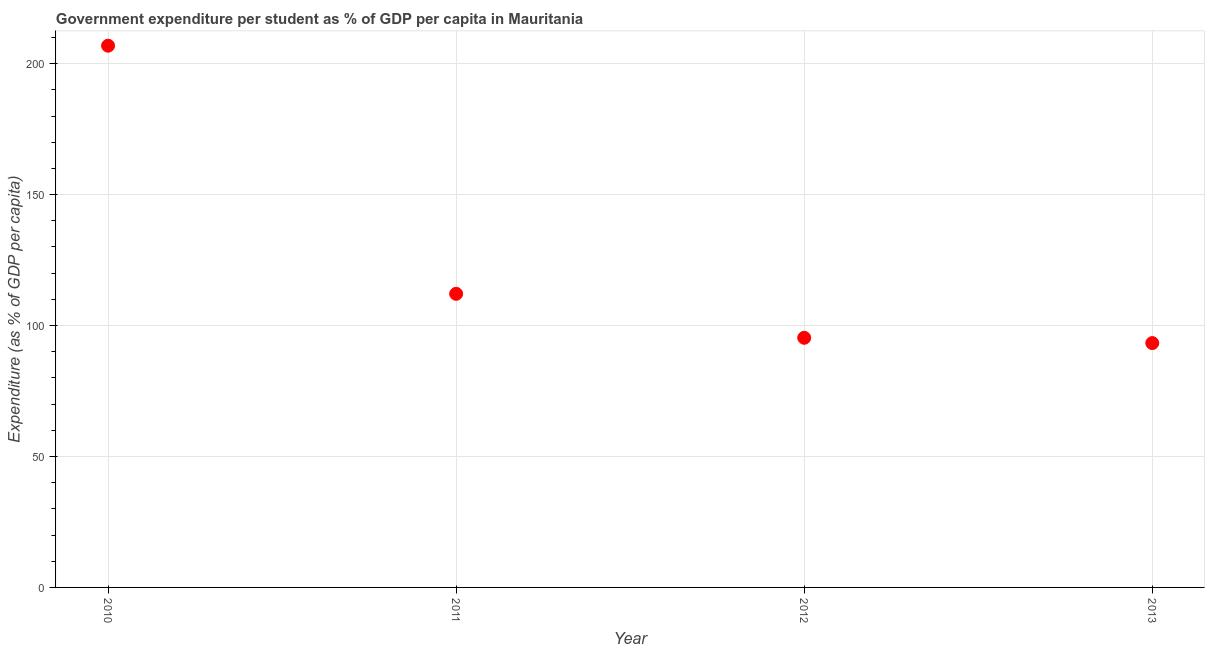What is the government expenditure per student in 2012?
Keep it short and to the point. 95.32. Across all years, what is the maximum government expenditure per student?
Your answer should be compact. 206.85. Across all years, what is the minimum government expenditure per student?
Make the answer very short. 93.3. In which year was the government expenditure per student maximum?
Ensure brevity in your answer.  2010. What is the sum of the government expenditure per student?
Ensure brevity in your answer.  507.58. What is the difference between the government expenditure per student in 2010 and 2011?
Keep it short and to the point. 94.74. What is the average government expenditure per student per year?
Your answer should be very brief. 126.9. What is the median government expenditure per student?
Give a very brief answer. 103.72. Do a majority of the years between 2011 and 2010 (inclusive) have government expenditure per student greater than 20 %?
Make the answer very short. No. What is the ratio of the government expenditure per student in 2010 to that in 2012?
Your answer should be compact. 2.17. Is the government expenditure per student in 2010 less than that in 2012?
Provide a succinct answer. No. What is the difference between the highest and the second highest government expenditure per student?
Ensure brevity in your answer.  94.74. What is the difference between the highest and the lowest government expenditure per student?
Offer a very short reply. 113.55. In how many years, is the government expenditure per student greater than the average government expenditure per student taken over all years?
Provide a short and direct response. 1. How many years are there in the graph?
Your answer should be very brief. 4. What is the difference between two consecutive major ticks on the Y-axis?
Provide a short and direct response. 50. Does the graph contain any zero values?
Your response must be concise. No. What is the title of the graph?
Your answer should be very brief. Government expenditure per student as % of GDP per capita in Mauritania. What is the label or title of the X-axis?
Your answer should be very brief. Year. What is the label or title of the Y-axis?
Offer a very short reply. Expenditure (as % of GDP per capita). What is the Expenditure (as % of GDP per capita) in 2010?
Your response must be concise. 206.85. What is the Expenditure (as % of GDP per capita) in 2011?
Provide a short and direct response. 112.11. What is the Expenditure (as % of GDP per capita) in 2012?
Your answer should be compact. 95.32. What is the Expenditure (as % of GDP per capita) in 2013?
Your answer should be very brief. 93.3. What is the difference between the Expenditure (as % of GDP per capita) in 2010 and 2011?
Provide a short and direct response. 94.74. What is the difference between the Expenditure (as % of GDP per capita) in 2010 and 2012?
Your answer should be compact. 111.53. What is the difference between the Expenditure (as % of GDP per capita) in 2010 and 2013?
Provide a succinct answer. 113.55. What is the difference between the Expenditure (as % of GDP per capita) in 2011 and 2012?
Your answer should be compact. 16.79. What is the difference between the Expenditure (as % of GDP per capita) in 2011 and 2013?
Make the answer very short. 18.81. What is the difference between the Expenditure (as % of GDP per capita) in 2012 and 2013?
Give a very brief answer. 2.02. What is the ratio of the Expenditure (as % of GDP per capita) in 2010 to that in 2011?
Ensure brevity in your answer.  1.84. What is the ratio of the Expenditure (as % of GDP per capita) in 2010 to that in 2012?
Give a very brief answer. 2.17. What is the ratio of the Expenditure (as % of GDP per capita) in 2010 to that in 2013?
Your response must be concise. 2.22. What is the ratio of the Expenditure (as % of GDP per capita) in 2011 to that in 2012?
Your answer should be compact. 1.18. What is the ratio of the Expenditure (as % of GDP per capita) in 2011 to that in 2013?
Give a very brief answer. 1.2. What is the ratio of the Expenditure (as % of GDP per capita) in 2012 to that in 2013?
Give a very brief answer. 1.02. 